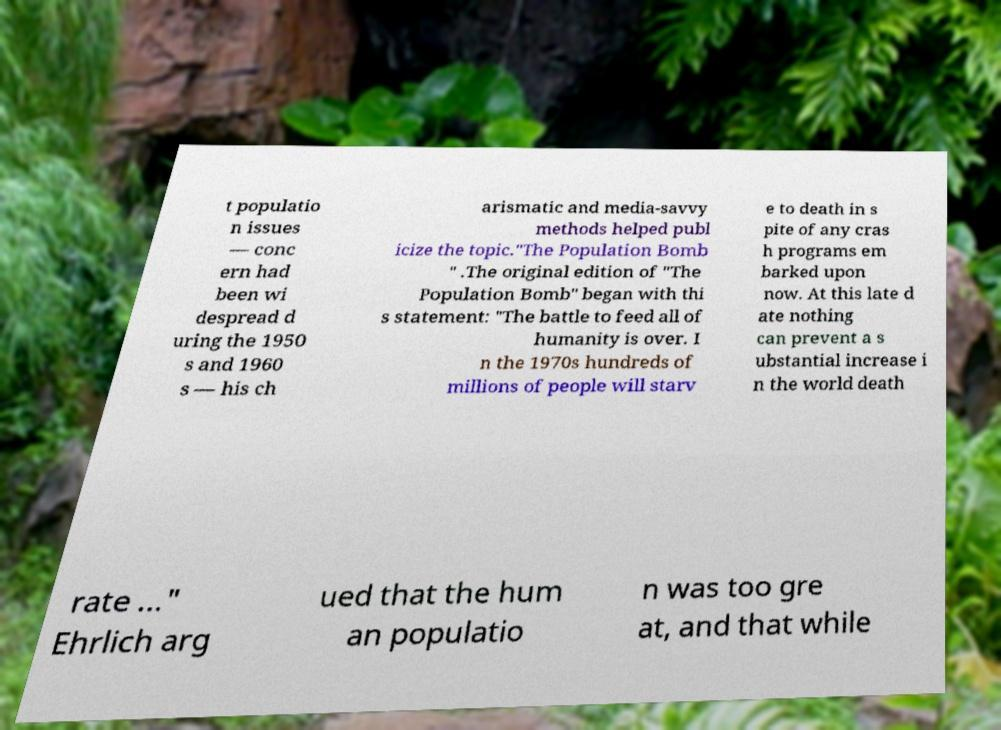Please read and relay the text visible in this image. What does it say? t populatio n issues — conc ern had been wi despread d uring the 1950 s and 1960 s — his ch arismatic and media-savvy methods helped publ icize the topic."The Population Bomb " .The original edition of "The Population Bomb" began with thi s statement: "The battle to feed all of humanity is over. I n the 1970s hundreds of millions of people will starv e to death in s pite of any cras h programs em barked upon now. At this late d ate nothing can prevent a s ubstantial increase i n the world death rate ..." Ehrlich arg ued that the hum an populatio n was too gre at, and that while 